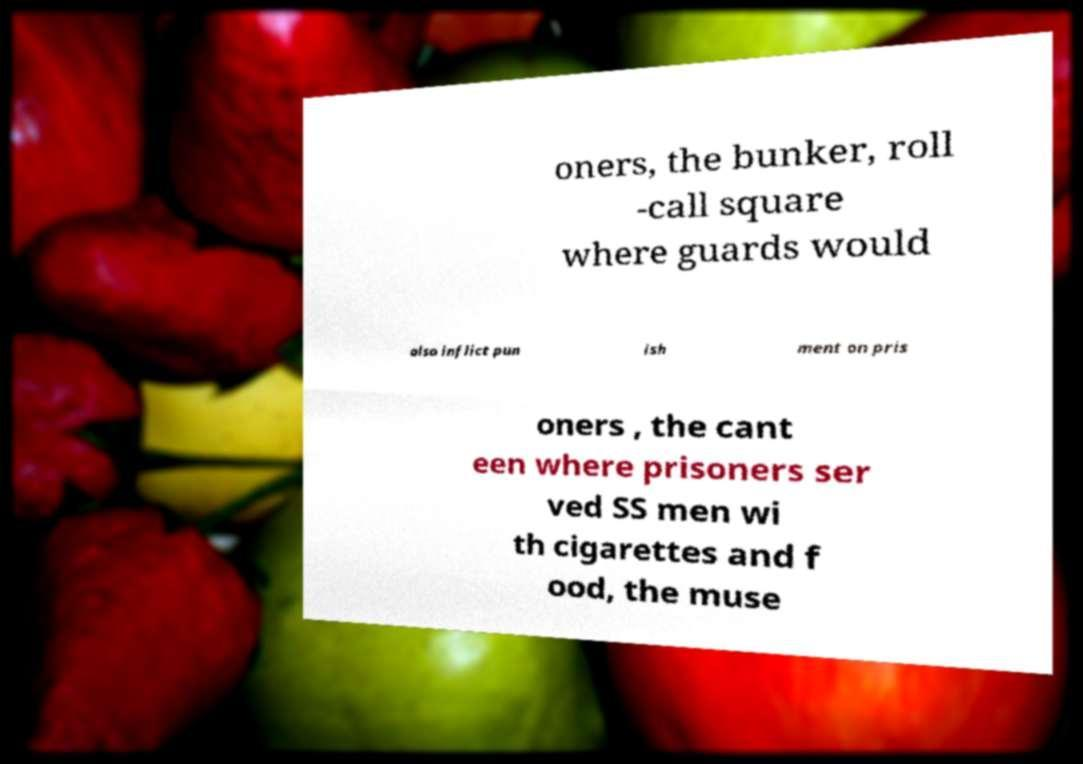What messages or text are displayed in this image? I need them in a readable, typed format. oners, the bunker, roll -call square where guards would also inflict pun ish ment on pris oners , the cant een where prisoners ser ved SS men wi th cigarettes and f ood, the muse 